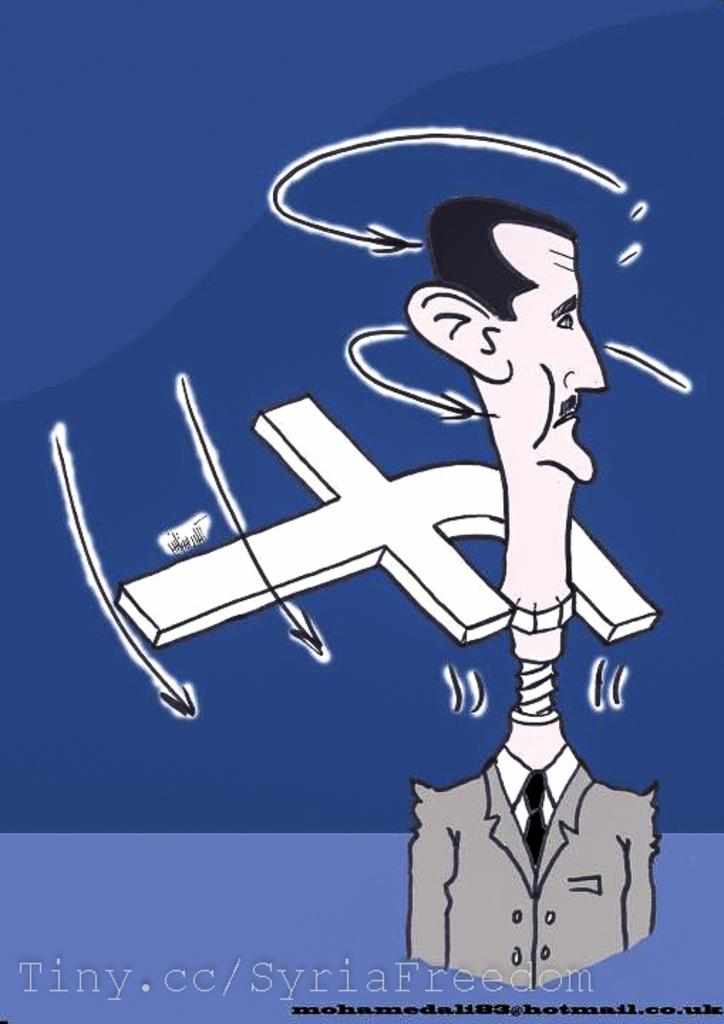<image>
Provide a brief description of the given image. animated graphic presented by Tiny.cc/syriafreedom, in a blue background. 